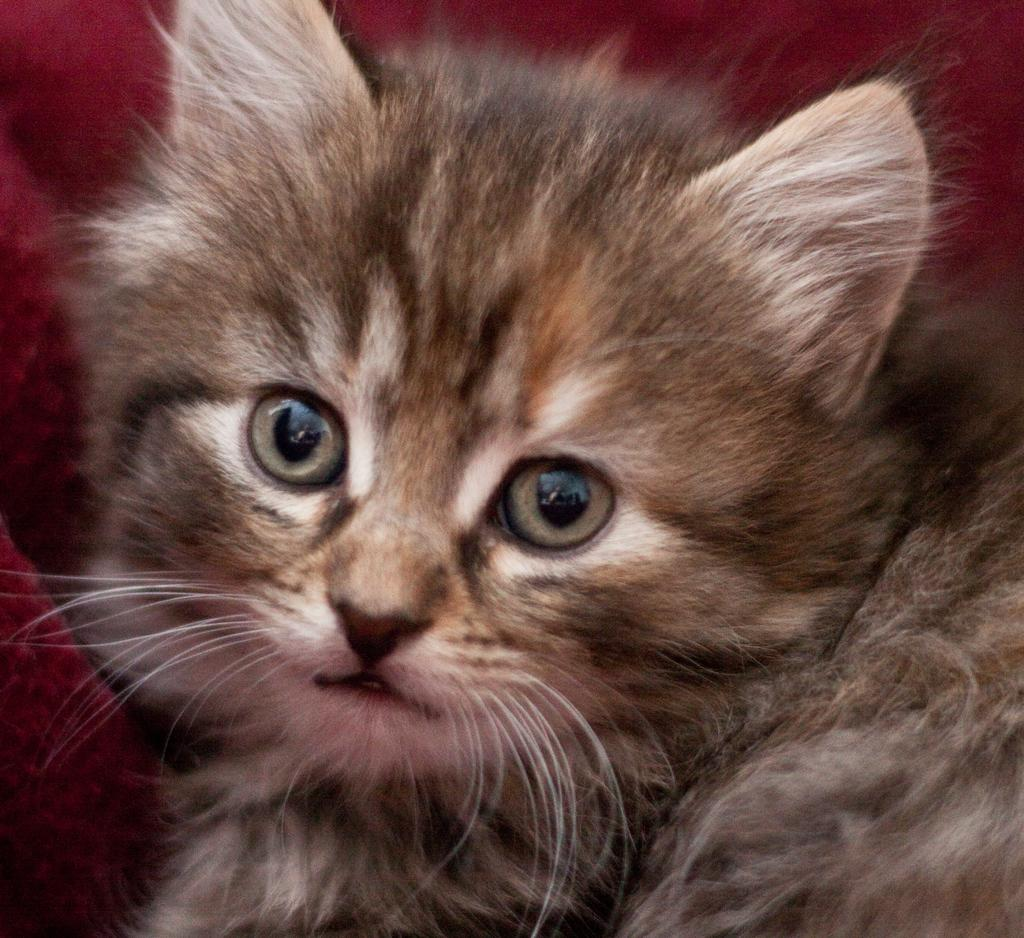What type of animal is in the image? There is a cat in the image. What color is the background of the image? The background of the image is maroon. How many cherries are on the cat's head in the image? There are no cherries present in the image, and the cat's head is not mentioned in the provided facts. 